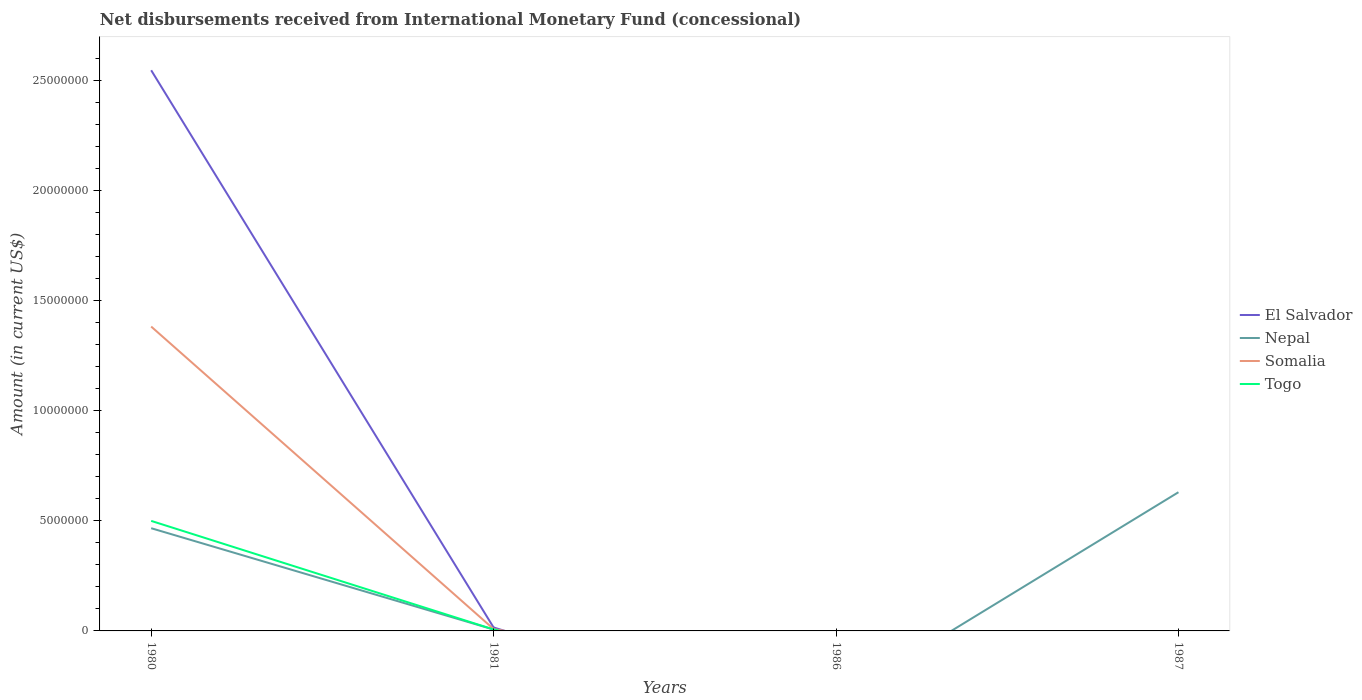Does the line corresponding to Togo intersect with the line corresponding to El Salvador?
Offer a terse response. Yes. Across all years, what is the maximum amount of disbursements received from International Monetary Fund in Somalia?
Offer a very short reply. 0. What is the total amount of disbursements received from International Monetary Fund in Nepal in the graph?
Make the answer very short. -1.64e+06. What is the difference between the highest and the second highest amount of disbursements received from International Monetary Fund in El Salvador?
Make the answer very short. 2.55e+07. What is the difference between the highest and the lowest amount of disbursements received from International Monetary Fund in Nepal?
Provide a succinct answer. 2. How many lines are there?
Provide a short and direct response. 4. How many years are there in the graph?
Your answer should be very brief. 4. What is the difference between two consecutive major ticks on the Y-axis?
Make the answer very short. 5.00e+06. Does the graph contain grids?
Offer a terse response. No. Where does the legend appear in the graph?
Keep it short and to the point. Center right. What is the title of the graph?
Make the answer very short. Net disbursements received from International Monetary Fund (concessional). What is the label or title of the Y-axis?
Provide a succinct answer. Amount (in current US$). What is the Amount (in current US$) of El Salvador in 1980?
Make the answer very short. 2.55e+07. What is the Amount (in current US$) of Nepal in 1980?
Ensure brevity in your answer.  4.66e+06. What is the Amount (in current US$) in Somalia in 1980?
Your response must be concise. 1.38e+07. What is the Amount (in current US$) in Togo in 1980?
Keep it short and to the point. 5.00e+06. What is the Amount (in current US$) of El Salvador in 1981?
Your answer should be very brief. 1.56e+05. What is the Amount (in current US$) of Nepal in 1981?
Your response must be concise. 6.30e+04. What is the Amount (in current US$) of Somalia in 1981?
Make the answer very short. 8.50e+04. What is the Amount (in current US$) of Togo in 1981?
Your answer should be compact. 6.70e+04. What is the Amount (in current US$) in El Salvador in 1986?
Ensure brevity in your answer.  0. What is the Amount (in current US$) in Nepal in 1986?
Give a very brief answer. 0. What is the Amount (in current US$) of Nepal in 1987?
Offer a very short reply. 6.30e+06. What is the Amount (in current US$) of Togo in 1987?
Your response must be concise. 0. Across all years, what is the maximum Amount (in current US$) in El Salvador?
Provide a succinct answer. 2.55e+07. Across all years, what is the maximum Amount (in current US$) of Nepal?
Provide a short and direct response. 6.30e+06. Across all years, what is the maximum Amount (in current US$) of Somalia?
Ensure brevity in your answer.  1.38e+07. Across all years, what is the maximum Amount (in current US$) in Togo?
Your answer should be very brief. 5.00e+06. Across all years, what is the minimum Amount (in current US$) in El Salvador?
Make the answer very short. 0. Across all years, what is the minimum Amount (in current US$) of Togo?
Provide a short and direct response. 0. What is the total Amount (in current US$) of El Salvador in the graph?
Ensure brevity in your answer.  2.56e+07. What is the total Amount (in current US$) in Nepal in the graph?
Your response must be concise. 1.10e+07. What is the total Amount (in current US$) of Somalia in the graph?
Ensure brevity in your answer.  1.39e+07. What is the total Amount (in current US$) in Togo in the graph?
Offer a very short reply. 5.06e+06. What is the difference between the Amount (in current US$) in El Salvador in 1980 and that in 1981?
Keep it short and to the point. 2.53e+07. What is the difference between the Amount (in current US$) of Nepal in 1980 and that in 1981?
Your answer should be compact. 4.60e+06. What is the difference between the Amount (in current US$) in Somalia in 1980 and that in 1981?
Offer a very short reply. 1.37e+07. What is the difference between the Amount (in current US$) in Togo in 1980 and that in 1981?
Ensure brevity in your answer.  4.93e+06. What is the difference between the Amount (in current US$) of Nepal in 1980 and that in 1987?
Provide a succinct answer. -1.64e+06. What is the difference between the Amount (in current US$) in Nepal in 1981 and that in 1987?
Your response must be concise. -6.24e+06. What is the difference between the Amount (in current US$) of El Salvador in 1980 and the Amount (in current US$) of Nepal in 1981?
Your answer should be compact. 2.54e+07. What is the difference between the Amount (in current US$) of El Salvador in 1980 and the Amount (in current US$) of Somalia in 1981?
Offer a very short reply. 2.54e+07. What is the difference between the Amount (in current US$) in El Salvador in 1980 and the Amount (in current US$) in Togo in 1981?
Give a very brief answer. 2.54e+07. What is the difference between the Amount (in current US$) in Nepal in 1980 and the Amount (in current US$) in Somalia in 1981?
Provide a succinct answer. 4.58e+06. What is the difference between the Amount (in current US$) in Nepal in 1980 and the Amount (in current US$) in Togo in 1981?
Offer a very short reply. 4.60e+06. What is the difference between the Amount (in current US$) of Somalia in 1980 and the Amount (in current US$) of Togo in 1981?
Ensure brevity in your answer.  1.38e+07. What is the difference between the Amount (in current US$) in El Salvador in 1980 and the Amount (in current US$) in Nepal in 1987?
Make the answer very short. 1.92e+07. What is the difference between the Amount (in current US$) in El Salvador in 1981 and the Amount (in current US$) in Nepal in 1987?
Your response must be concise. -6.14e+06. What is the average Amount (in current US$) of El Salvador per year?
Give a very brief answer. 6.41e+06. What is the average Amount (in current US$) in Nepal per year?
Your response must be concise. 2.76e+06. What is the average Amount (in current US$) of Somalia per year?
Give a very brief answer. 3.48e+06. What is the average Amount (in current US$) of Togo per year?
Give a very brief answer. 1.27e+06. In the year 1980, what is the difference between the Amount (in current US$) of El Salvador and Amount (in current US$) of Nepal?
Keep it short and to the point. 2.08e+07. In the year 1980, what is the difference between the Amount (in current US$) in El Salvador and Amount (in current US$) in Somalia?
Your answer should be compact. 1.16e+07. In the year 1980, what is the difference between the Amount (in current US$) of El Salvador and Amount (in current US$) of Togo?
Offer a very short reply. 2.05e+07. In the year 1980, what is the difference between the Amount (in current US$) in Nepal and Amount (in current US$) in Somalia?
Provide a short and direct response. -9.16e+06. In the year 1980, what is the difference between the Amount (in current US$) in Nepal and Amount (in current US$) in Togo?
Your answer should be very brief. -3.33e+05. In the year 1980, what is the difference between the Amount (in current US$) of Somalia and Amount (in current US$) of Togo?
Offer a terse response. 8.83e+06. In the year 1981, what is the difference between the Amount (in current US$) in El Salvador and Amount (in current US$) in Nepal?
Offer a very short reply. 9.30e+04. In the year 1981, what is the difference between the Amount (in current US$) in El Salvador and Amount (in current US$) in Somalia?
Provide a short and direct response. 7.10e+04. In the year 1981, what is the difference between the Amount (in current US$) of El Salvador and Amount (in current US$) of Togo?
Your answer should be very brief. 8.90e+04. In the year 1981, what is the difference between the Amount (in current US$) of Nepal and Amount (in current US$) of Somalia?
Provide a succinct answer. -2.20e+04. In the year 1981, what is the difference between the Amount (in current US$) of Nepal and Amount (in current US$) of Togo?
Keep it short and to the point. -4000. In the year 1981, what is the difference between the Amount (in current US$) in Somalia and Amount (in current US$) in Togo?
Your answer should be very brief. 1.80e+04. What is the ratio of the Amount (in current US$) in El Salvador in 1980 to that in 1981?
Give a very brief answer. 163.24. What is the ratio of the Amount (in current US$) in Nepal in 1980 to that in 1981?
Your answer should be compact. 74.05. What is the ratio of the Amount (in current US$) in Somalia in 1980 to that in 1981?
Provide a short and direct response. 162.64. What is the ratio of the Amount (in current US$) of Togo in 1980 to that in 1981?
Offer a very short reply. 74.6. What is the ratio of the Amount (in current US$) in Nepal in 1980 to that in 1987?
Your response must be concise. 0.74. What is the difference between the highest and the second highest Amount (in current US$) in Nepal?
Your response must be concise. 1.64e+06. What is the difference between the highest and the lowest Amount (in current US$) of El Salvador?
Your answer should be very brief. 2.55e+07. What is the difference between the highest and the lowest Amount (in current US$) in Nepal?
Keep it short and to the point. 6.30e+06. What is the difference between the highest and the lowest Amount (in current US$) of Somalia?
Your answer should be compact. 1.38e+07. What is the difference between the highest and the lowest Amount (in current US$) of Togo?
Make the answer very short. 5.00e+06. 